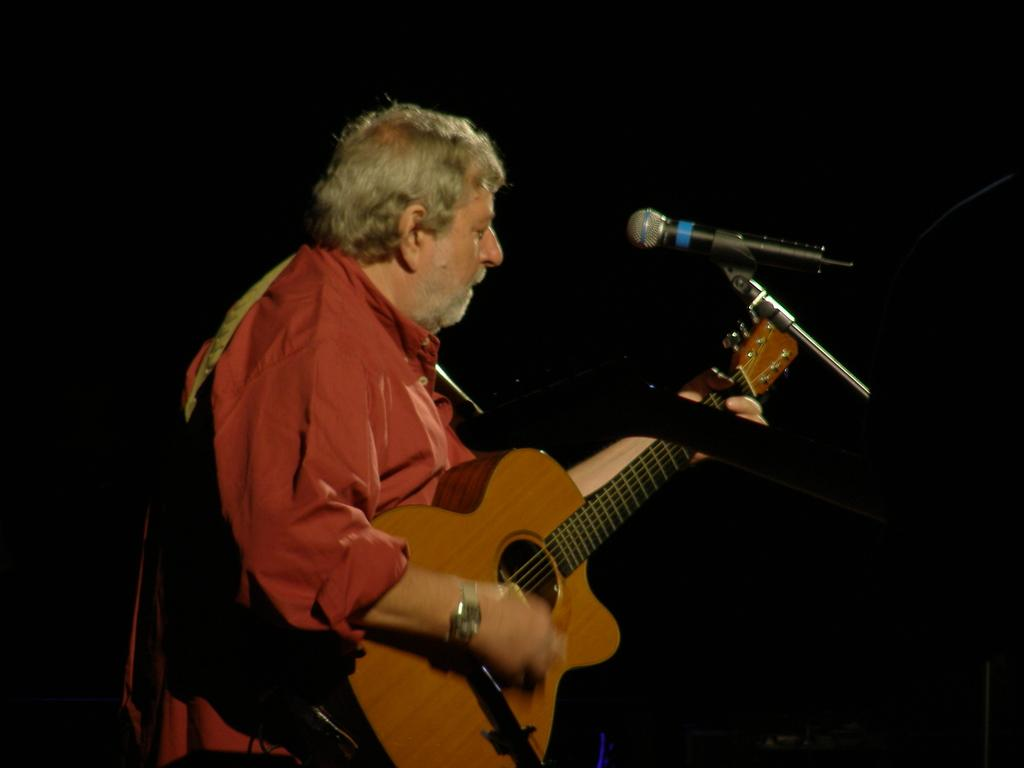What is the main subject of the image? There is a person in the image. What is the person doing in the image? The person is standing and holding a guitar. What object is present that is typically used for amplifying sound? There is a microphone in the image. What color is the shirt the person is wearing? The person is wearing a red shirt. What accessory is the person wearing on their wrist? The person is wearing a watch. How many answers can be seen in the image? There are no answers present in the image; it features a person holding a guitar and standing near a microphone. Is there a prison visible in the image? There is no prison present in the image. 